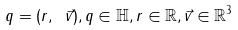<formula> <loc_0><loc_0><loc_500><loc_500>q = ( r , \ { \vec { v } } ) , q \in \mathbb { H } , r \in \mathbb { R } , { \vec { v } } \in \mathbb { R } ^ { 3 }</formula> 